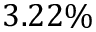<formula> <loc_0><loc_0><loc_500><loc_500>3 . 2 2 \%</formula> 